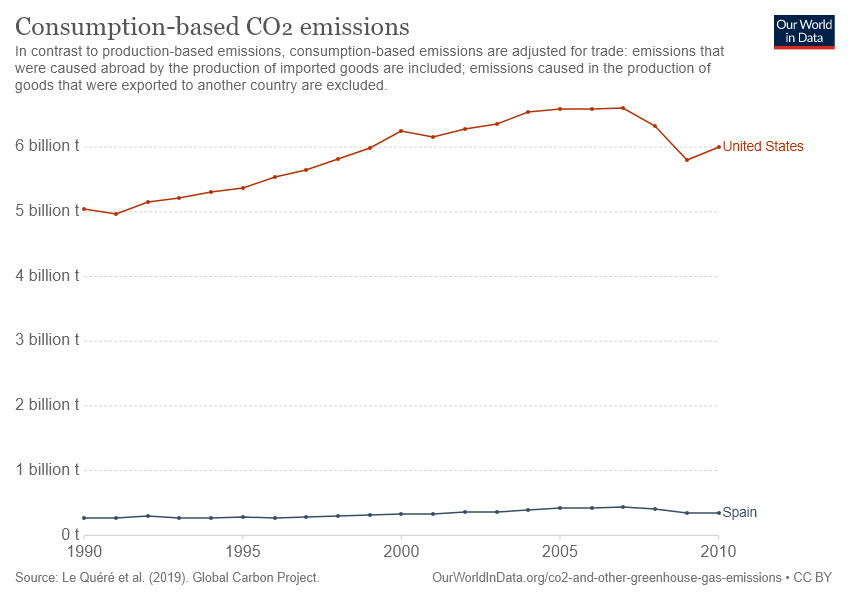Specify some key components in this picture. The graph shows data for Consumption-based CO2 emissions for two countries, which are the United States and Spain. The data for Spain shows an all-time low and a nearly straight line, indicating a steady and consistent trend. 